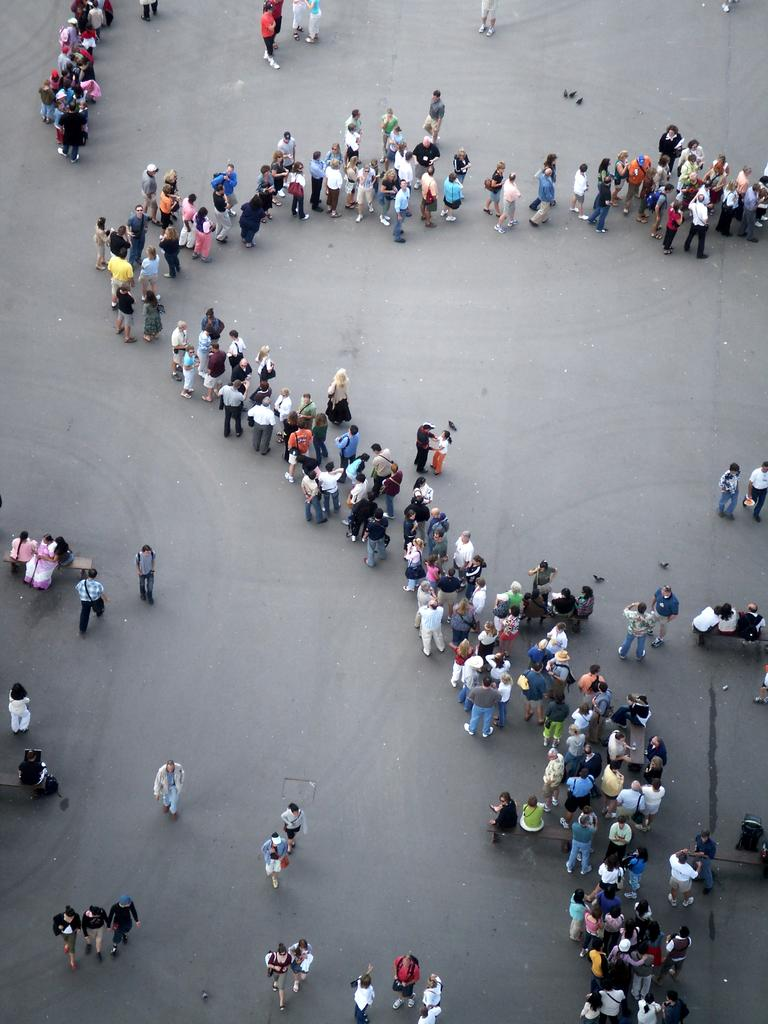What are the people in the image doing? There is a group of people standing in a line, and some people are walking on a path. Can you describe the actions of the people in the image? The group of people are standing in a line, while others are walking on a path. What color is the wing of the doll in the image? There is no doll or wing present in the image. 